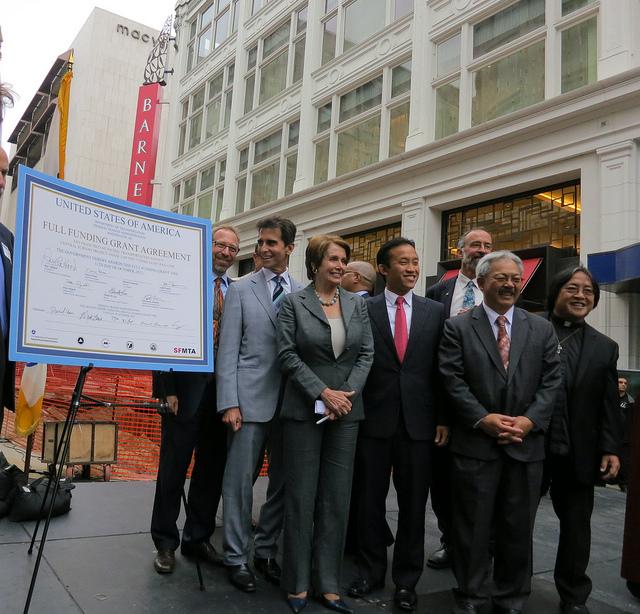What are the people posing for?
Give a very brief answer. Picture. How many people are in the photo?
Quick response, please. 8. Is the image in black and white?
Give a very brief answer. No. How many women are posing?
Write a very short answer. 1. Are they close to an elevator?
Give a very brief answer. No. Are the people friends?
Be succinct. Yes. How many men are shown?
Answer briefly. 7. What are the people protesting?
Quick response, please. Nothing. Are there any Asians posing?
Short answer required. Yes. 